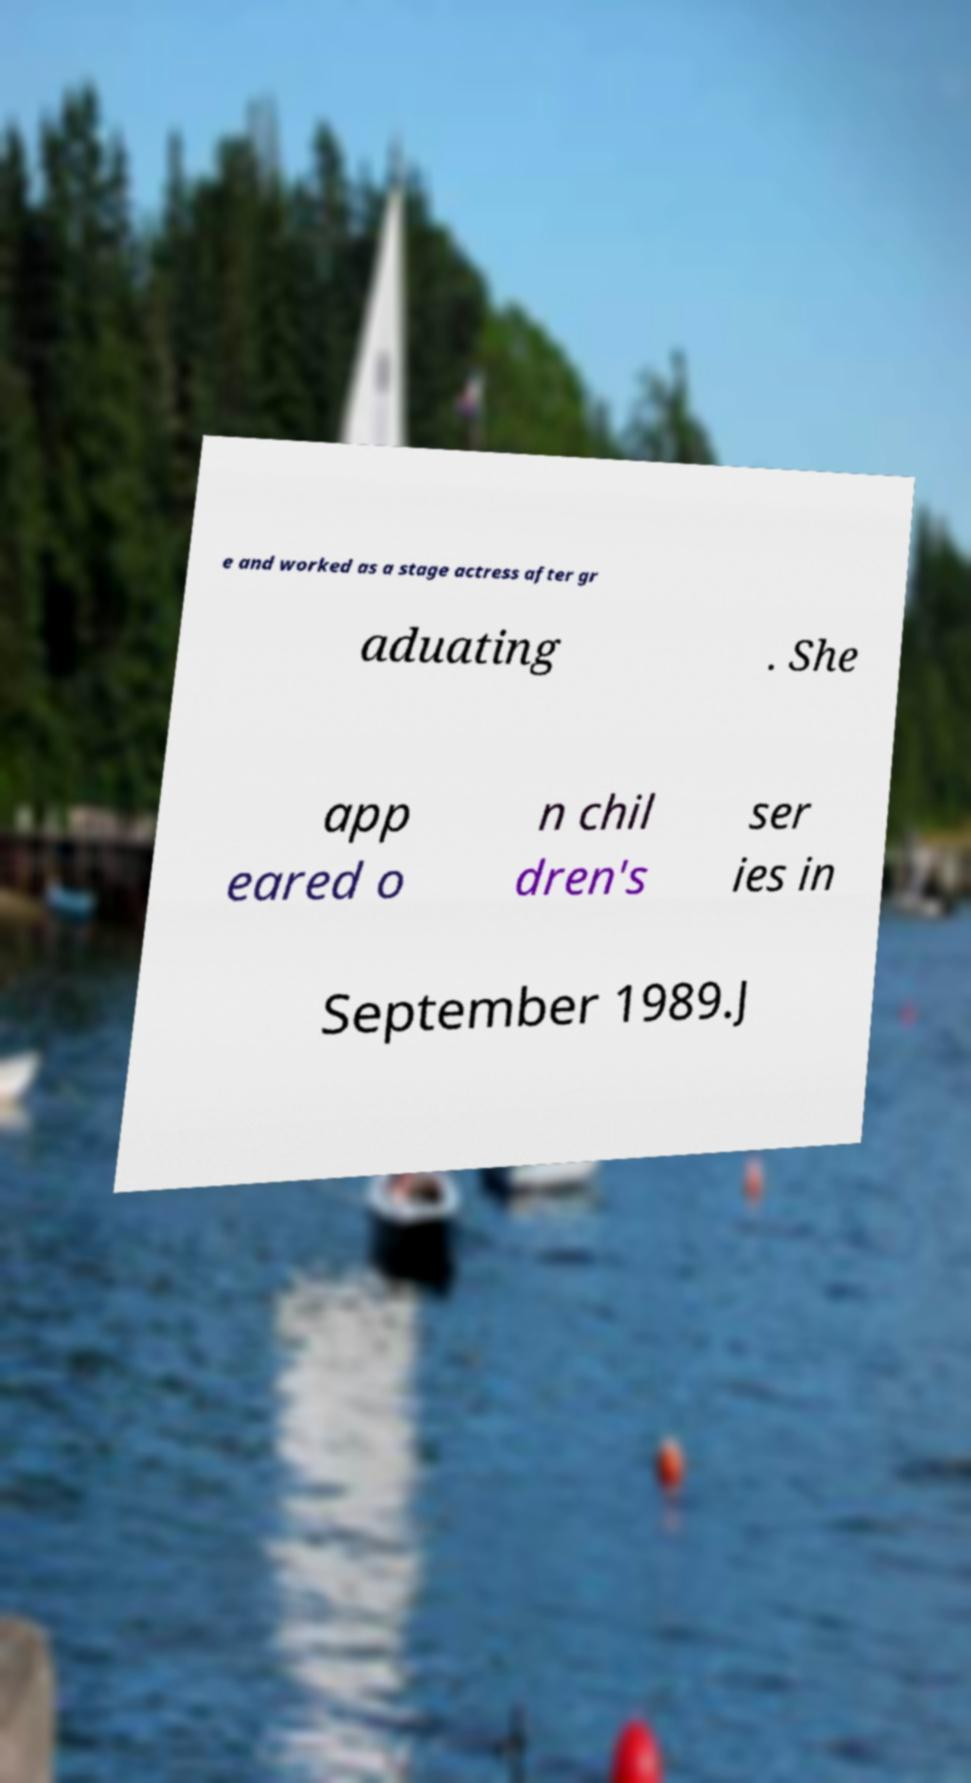Please identify and transcribe the text found in this image. e and worked as a stage actress after gr aduating . She app eared o n chil dren's ser ies in September 1989.J 